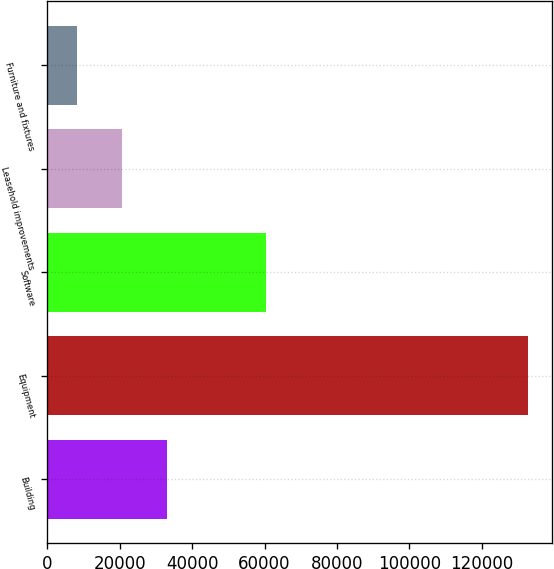Convert chart to OTSL. <chart><loc_0><loc_0><loc_500><loc_500><bar_chart><fcel>Building<fcel>Equipment<fcel>Software<fcel>Leasehold improvements<fcel>Furniture and fixtures<nl><fcel>33014.6<fcel>132677<fcel>60387<fcel>20556.8<fcel>8099<nl></chart> 